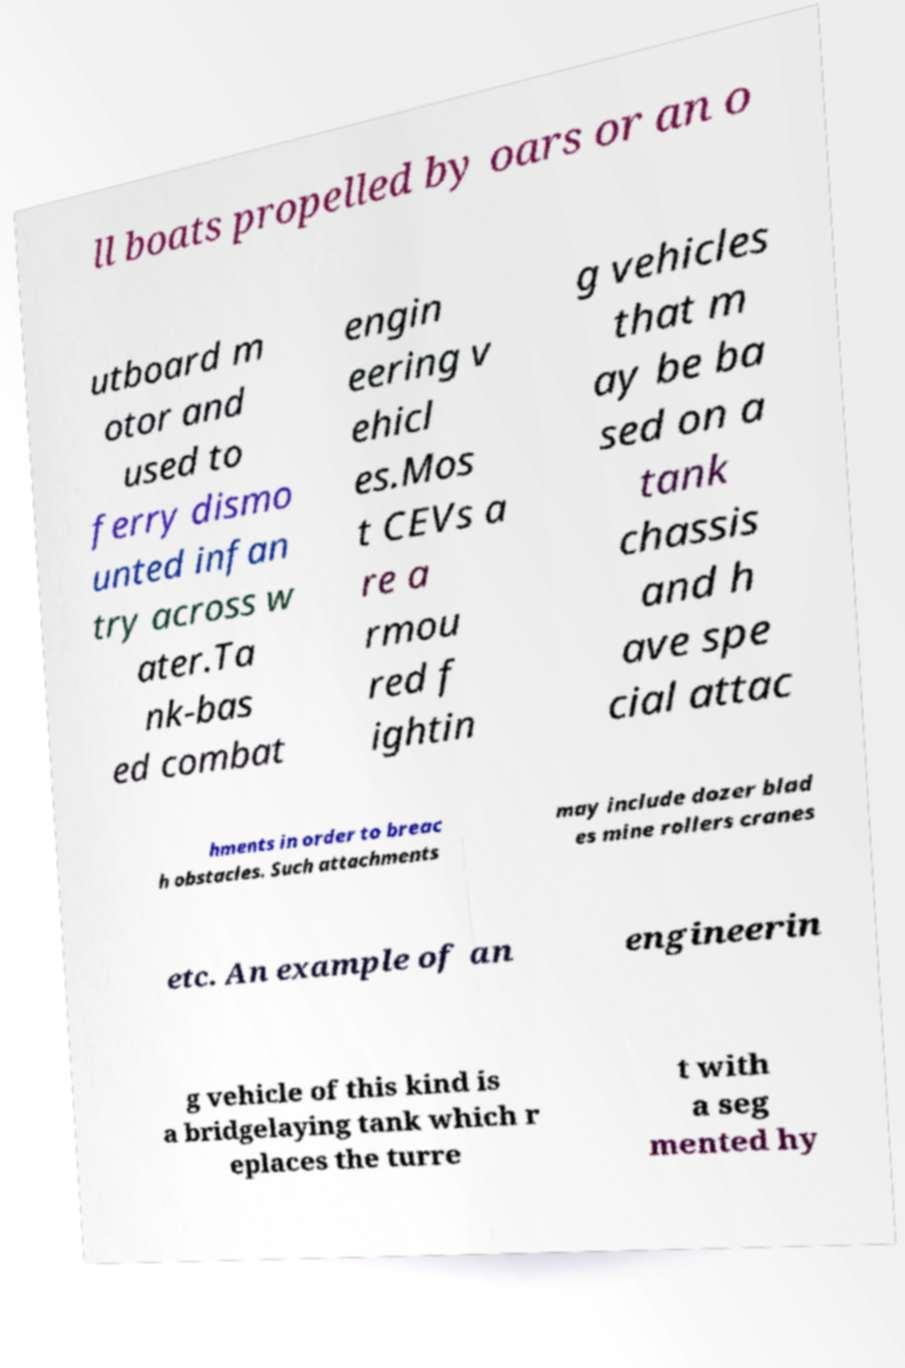Could you assist in decoding the text presented in this image and type it out clearly? ll boats propelled by oars or an o utboard m otor and used to ferry dismo unted infan try across w ater.Ta nk-bas ed combat engin eering v ehicl es.Mos t CEVs a re a rmou red f ightin g vehicles that m ay be ba sed on a tank chassis and h ave spe cial attac hments in order to breac h obstacles. Such attachments may include dozer blad es mine rollers cranes etc. An example of an engineerin g vehicle of this kind is a bridgelaying tank which r eplaces the turre t with a seg mented hy 